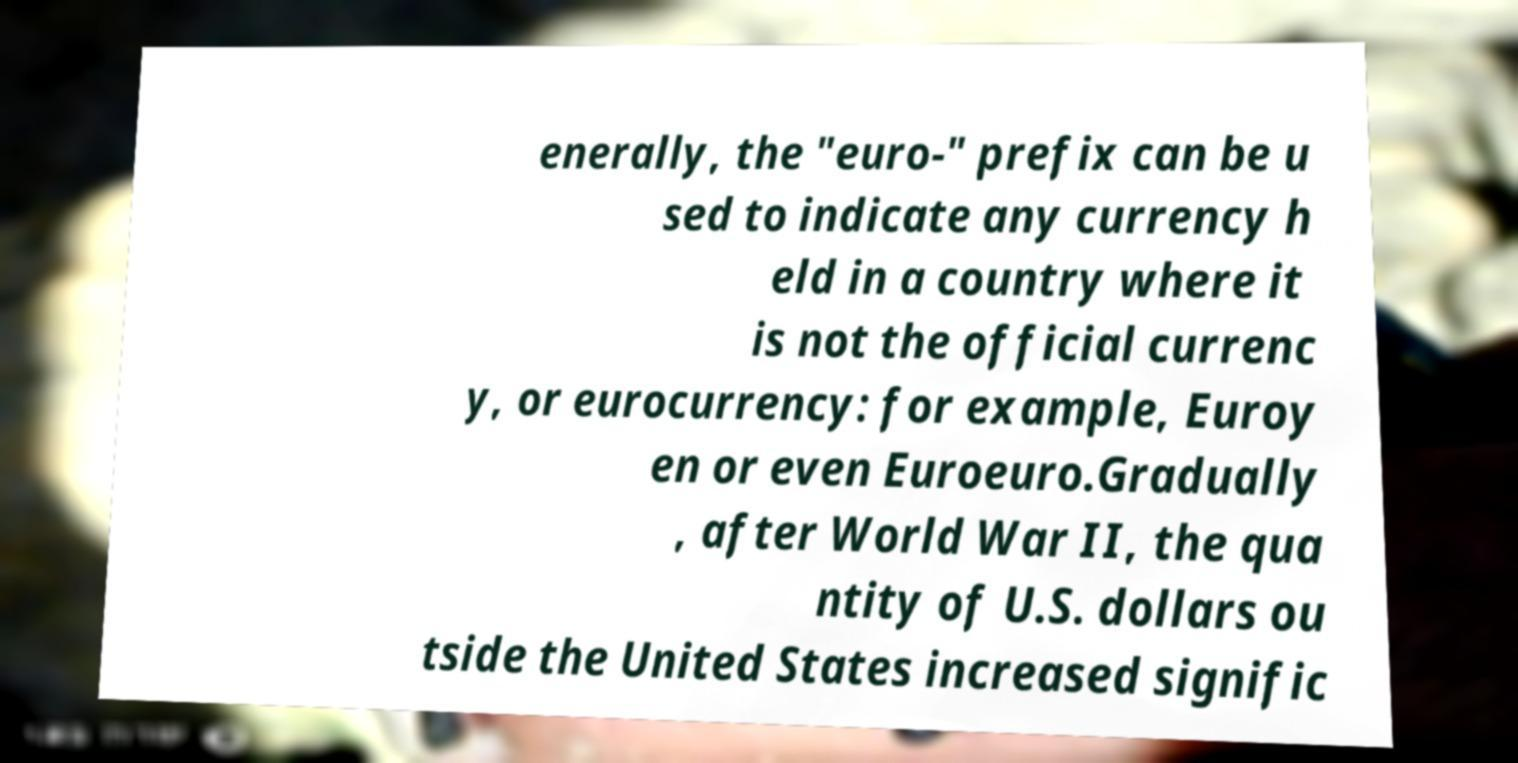Could you assist in decoding the text presented in this image and type it out clearly? enerally, the "euro-" prefix can be u sed to indicate any currency h eld in a country where it is not the official currenc y, or eurocurrency: for example, Euroy en or even Euroeuro.Gradually , after World War II, the qua ntity of U.S. dollars ou tside the United States increased signific 